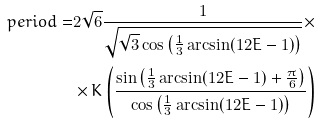<formula> <loc_0><loc_0><loc_500><loc_500>p e r i o d = & 2 \sqrt { 6 } \frac { 1 } { \sqrt { \sqrt { 3 } \cos \left ( \frac { 1 } { 3 } \arcsin ( 1 2 E - 1 ) \right ) } } \times \\ & \times K \left ( \frac { \sin \left ( \frac { 1 } { 3 } \arcsin ( 1 2 E - 1 ) + \frac { \pi } { 6 } \right ) } { \cos \left ( \frac { 1 } { 3 } \arcsin ( 1 2 E - 1 ) \right ) } \right )</formula> 